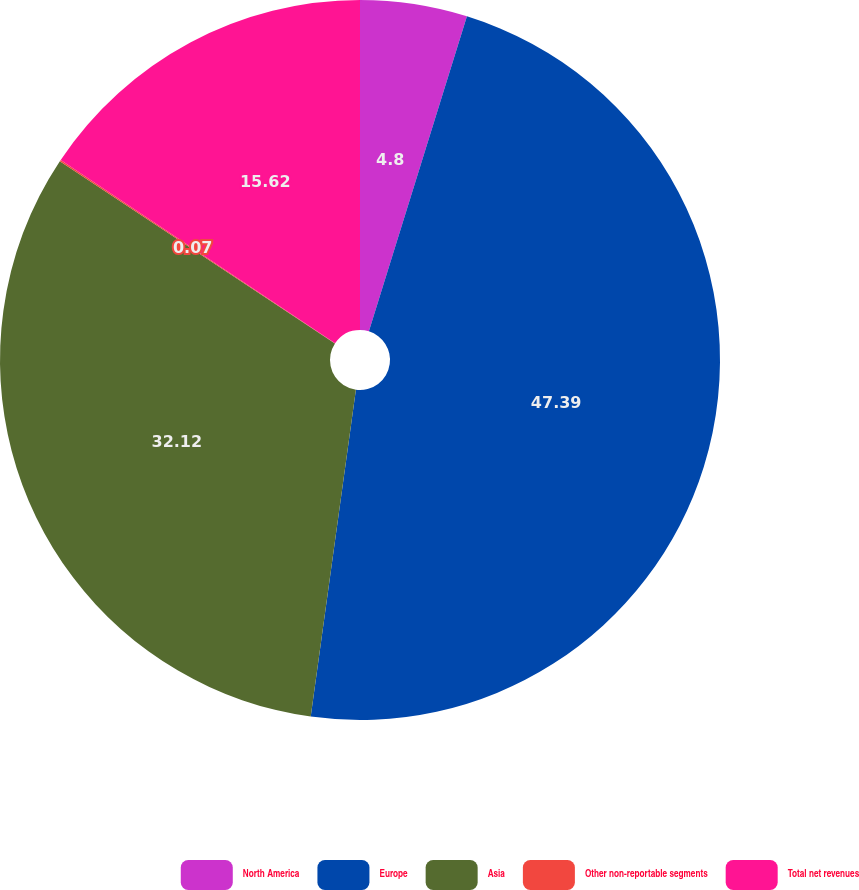<chart> <loc_0><loc_0><loc_500><loc_500><pie_chart><fcel>North America<fcel>Europe<fcel>Asia<fcel>Other non-reportable segments<fcel>Total net revenues<nl><fcel>4.8%<fcel>47.38%<fcel>32.12%<fcel>0.07%<fcel>15.62%<nl></chart> 